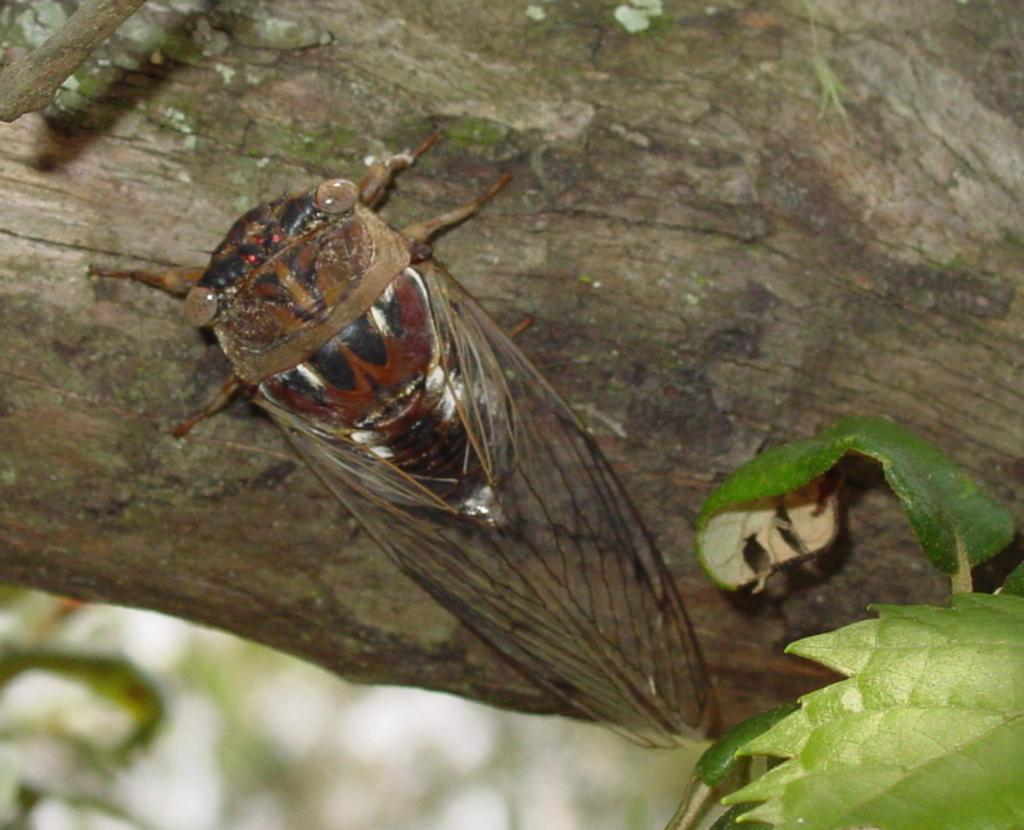What type of creature can be seen in the image? There is an insect in the image. Where is the insect located? The insect is on tree bark. What other natural elements can be seen in the image? There are leaves visible in the image. How many legs can be seen on the sink in the image? There is no sink present in the image, so it is not possible to determine the number of legs on a sink. 